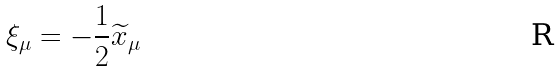Convert formula to latex. <formula><loc_0><loc_0><loc_500><loc_500>\xi _ { \mu } = - \frac { 1 } { 2 } \widetilde { x } _ { \mu }</formula> 